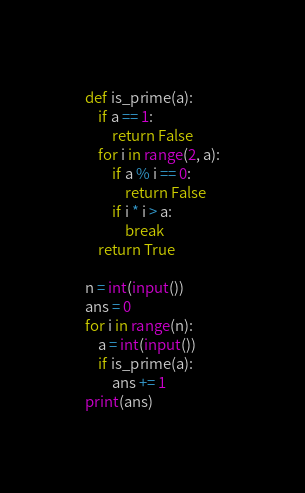Convert code to text. <code><loc_0><loc_0><loc_500><loc_500><_Python_>def is_prime(a):
    if a == 1:
        return False
    for i in range(2, a):
        if a % i == 0:
            return False
        if i * i > a:
            break
    return True

n = int(input())
ans = 0
for i in range(n):
    a = int(input())
    if is_prime(a):
        ans += 1
print(ans)
</code> 